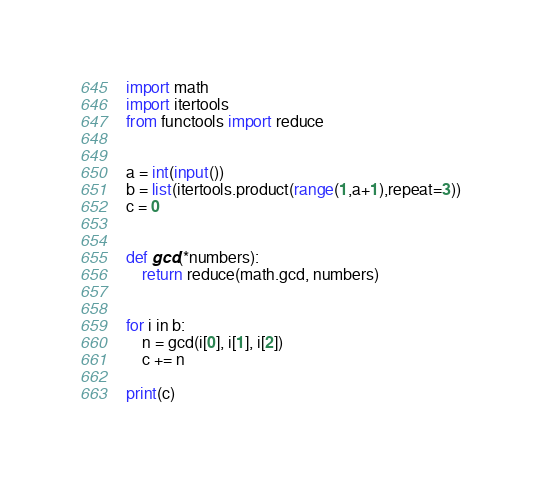Convert code to text. <code><loc_0><loc_0><loc_500><loc_500><_Python_>import math
import itertools
from functools import reduce


a = int(input())
b = list(itertools.product(range(1,a+1),repeat=3))
c = 0


def gcd(*numbers):
    return reduce(math.gcd, numbers)


for i in b:
    n = gcd(i[0], i[1], i[2])
    c += n

print(c)

</code> 